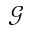<formula> <loc_0><loc_0><loc_500><loc_500>\mathcal { G }</formula> 